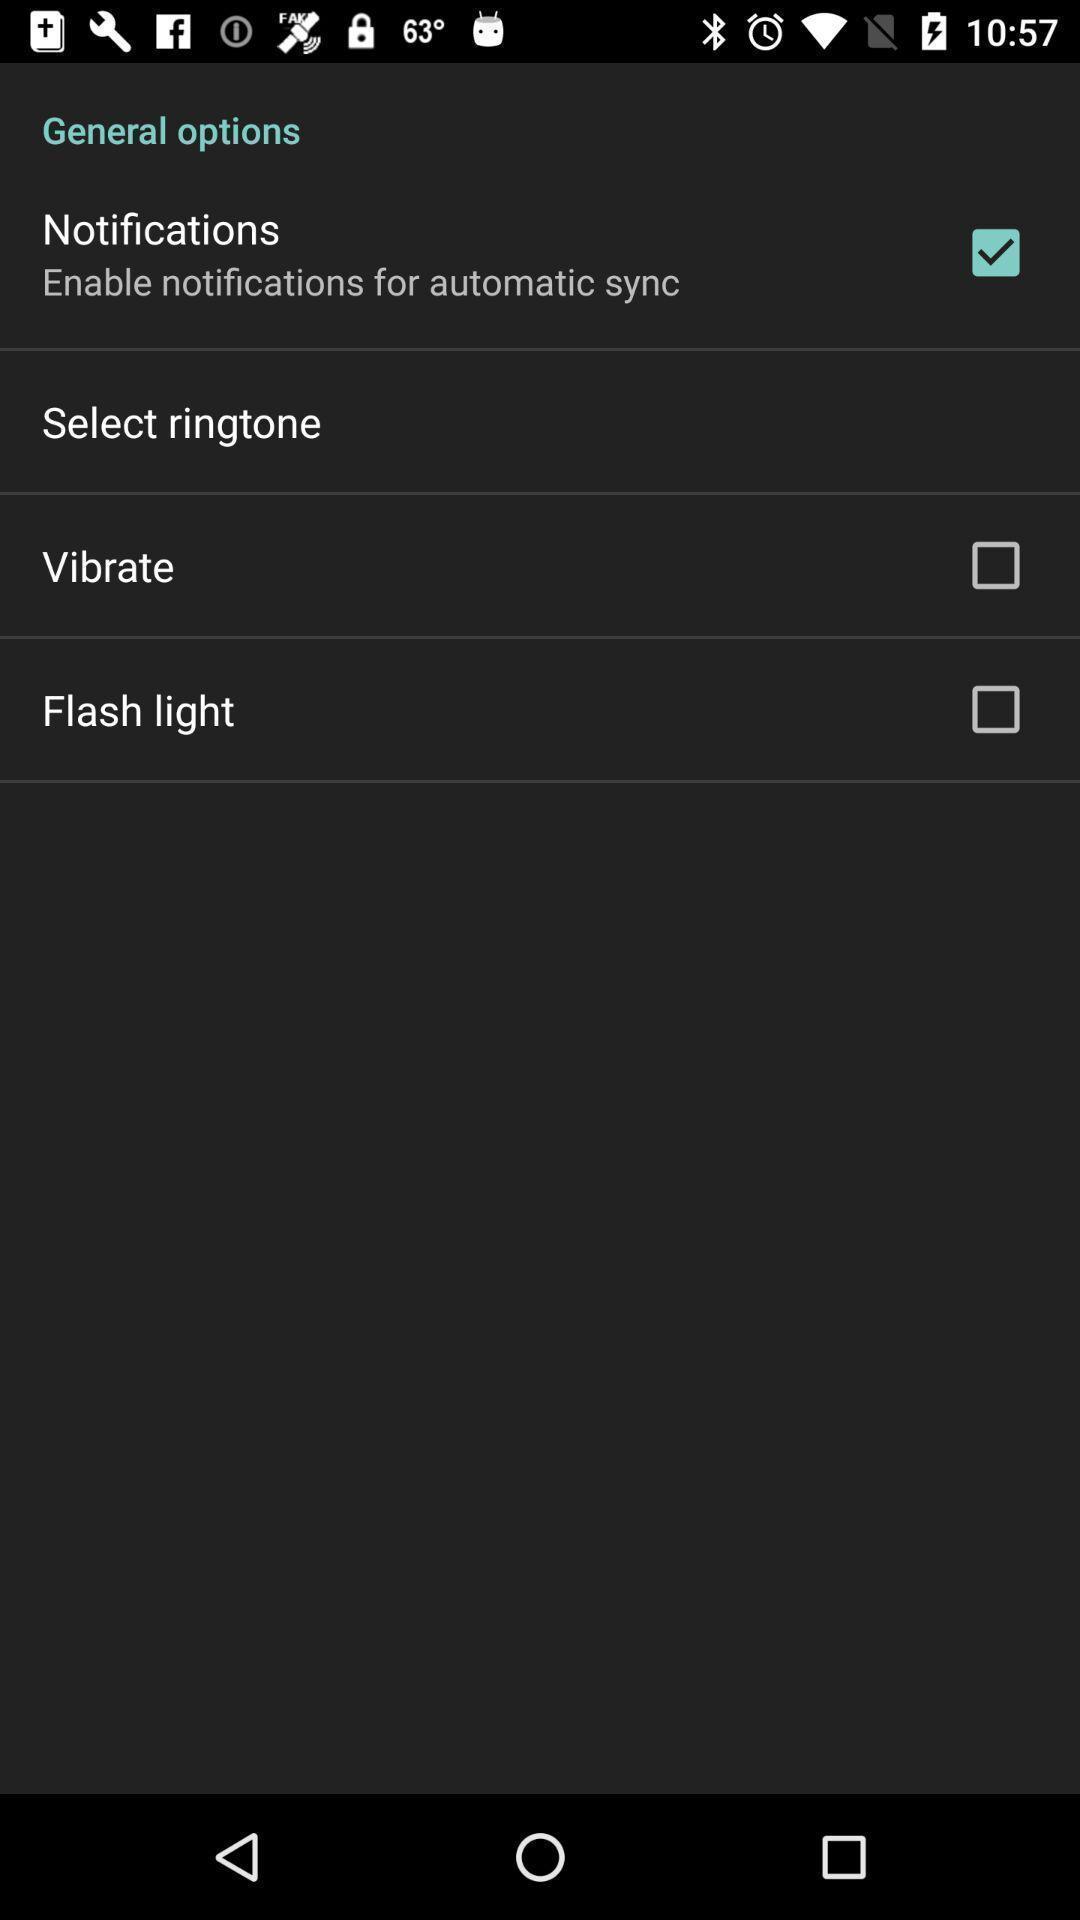Describe the key features of this screenshot. Page showing general options. 